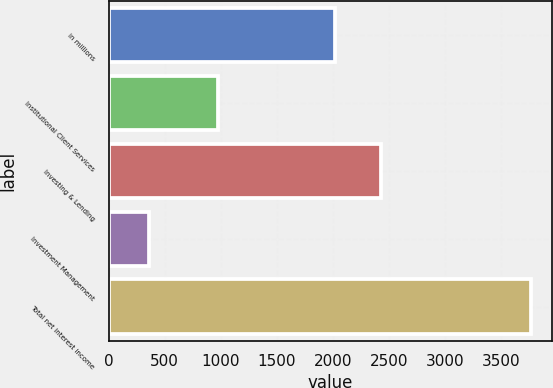Convert chart to OTSL. <chart><loc_0><loc_0><loc_500><loc_500><bar_chart><fcel>in millions<fcel>Institutional Client Services<fcel>Investing & Lending<fcel>Investment Management<fcel>Total net interest income<nl><fcel>2018<fcel>976<fcel>2427<fcel>364<fcel>3767<nl></chart> 